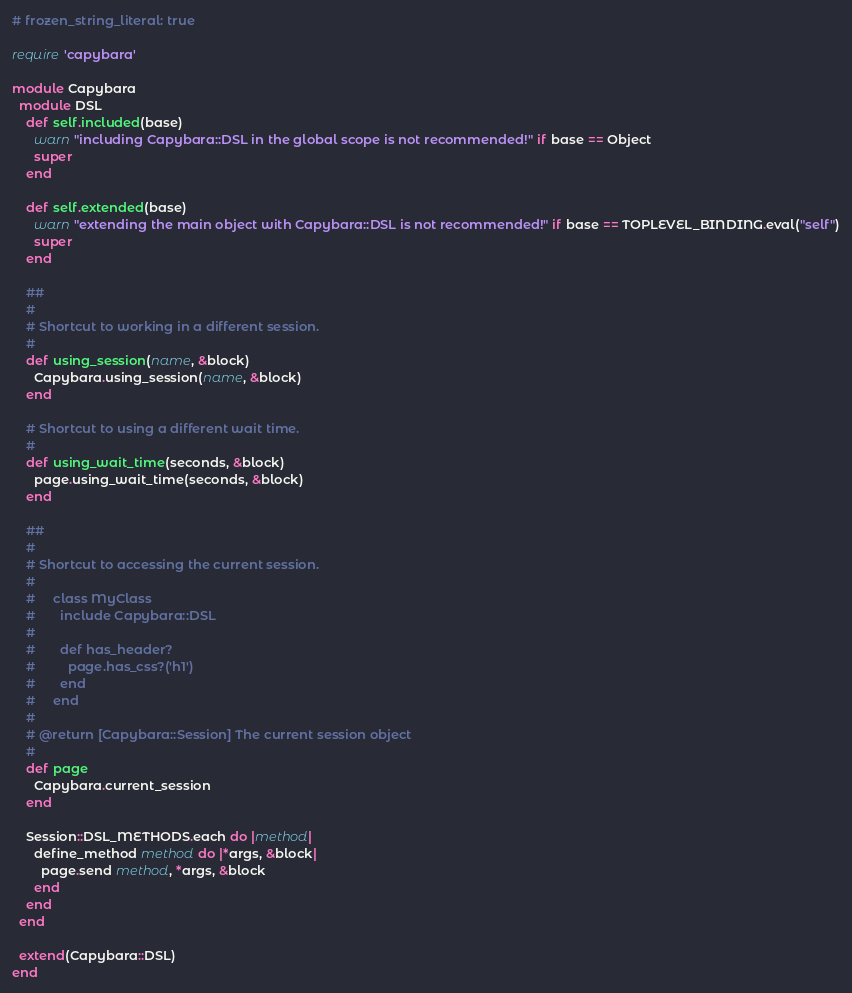Convert code to text. <code><loc_0><loc_0><loc_500><loc_500><_Ruby_># frozen_string_literal: true

require 'capybara'

module Capybara
  module DSL
    def self.included(base)
      warn "including Capybara::DSL in the global scope is not recommended!" if base == Object
      super
    end

    def self.extended(base)
      warn "extending the main object with Capybara::DSL is not recommended!" if base == TOPLEVEL_BINDING.eval("self")
      super
    end

    ##
    #
    # Shortcut to working in a different session.
    #
    def using_session(name, &block)
      Capybara.using_session(name, &block)
    end

    # Shortcut to using a different wait time.
    #
    def using_wait_time(seconds, &block)
      page.using_wait_time(seconds, &block)
    end

    ##
    #
    # Shortcut to accessing the current session.
    #
    #     class MyClass
    #       include Capybara::DSL
    #
    #       def has_header?
    #         page.has_css?('h1')
    #       end
    #     end
    #
    # @return [Capybara::Session] The current session object
    #
    def page
      Capybara.current_session
    end

    Session::DSL_METHODS.each do |method|
      define_method method do |*args, &block|
        page.send method, *args, &block
      end
    end
  end

  extend(Capybara::DSL)
end
</code> 